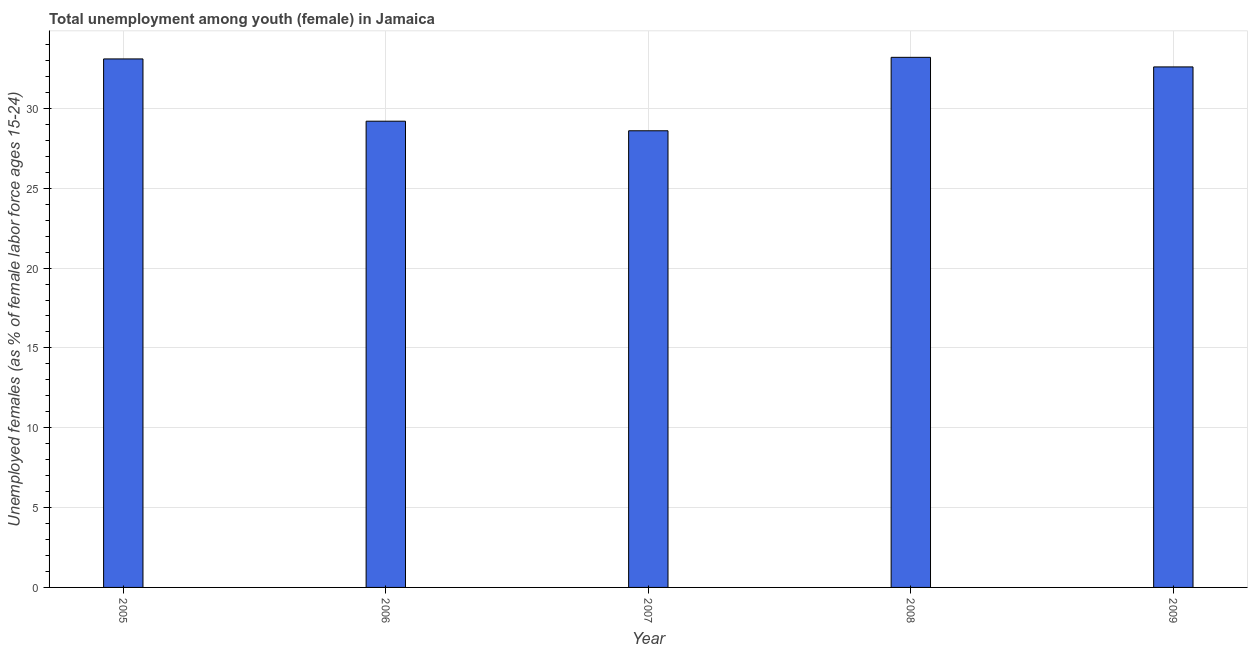Does the graph contain any zero values?
Make the answer very short. No. What is the title of the graph?
Offer a terse response. Total unemployment among youth (female) in Jamaica. What is the label or title of the X-axis?
Provide a short and direct response. Year. What is the label or title of the Y-axis?
Your response must be concise. Unemployed females (as % of female labor force ages 15-24). What is the unemployed female youth population in 2005?
Your answer should be compact. 33.1. Across all years, what is the maximum unemployed female youth population?
Offer a terse response. 33.2. Across all years, what is the minimum unemployed female youth population?
Your answer should be compact. 28.6. In which year was the unemployed female youth population maximum?
Provide a succinct answer. 2008. What is the sum of the unemployed female youth population?
Provide a short and direct response. 156.7. What is the difference between the unemployed female youth population in 2005 and 2008?
Offer a very short reply. -0.1. What is the average unemployed female youth population per year?
Your answer should be compact. 31.34. What is the median unemployed female youth population?
Keep it short and to the point. 32.6. In how many years, is the unemployed female youth population greater than 7 %?
Offer a terse response. 5. Do a majority of the years between 2009 and 2006 (inclusive) have unemployed female youth population greater than 20 %?
Give a very brief answer. Yes. What is the ratio of the unemployed female youth population in 2005 to that in 2006?
Your answer should be very brief. 1.13. Is the sum of the unemployed female youth population in 2005 and 2006 greater than the maximum unemployed female youth population across all years?
Make the answer very short. Yes. What is the difference between the highest and the lowest unemployed female youth population?
Keep it short and to the point. 4.6. Are all the bars in the graph horizontal?
Keep it short and to the point. No. What is the Unemployed females (as % of female labor force ages 15-24) of 2005?
Make the answer very short. 33.1. What is the Unemployed females (as % of female labor force ages 15-24) of 2006?
Give a very brief answer. 29.2. What is the Unemployed females (as % of female labor force ages 15-24) of 2007?
Provide a short and direct response. 28.6. What is the Unemployed females (as % of female labor force ages 15-24) in 2008?
Provide a short and direct response. 33.2. What is the Unemployed females (as % of female labor force ages 15-24) of 2009?
Your answer should be compact. 32.6. What is the difference between the Unemployed females (as % of female labor force ages 15-24) in 2006 and 2008?
Your answer should be very brief. -4. What is the difference between the Unemployed females (as % of female labor force ages 15-24) in 2006 and 2009?
Provide a short and direct response. -3.4. What is the difference between the Unemployed females (as % of female labor force ages 15-24) in 2008 and 2009?
Provide a short and direct response. 0.6. What is the ratio of the Unemployed females (as % of female labor force ages 15-24) in 2005 to that in 2006?
Offer a very short reply. 1.13. What is the ratio of the Unemployed females (as % of female labor force ages 15-24) in 2005 to that in 2007?
Provide a succinct answer. 1.16. What is the ratio of the Unemployed females (as % of female labor force ages 15-24) in 2005 to that in 2009?
Offer a very short reply. 1.01. What is the ratio of the Unemployed females (as % of female labor force ages 15-24) in 2006 to that in 2007?
Offer a very short reply. 1.02. What is the ratio of the Unemployed females (as % of female labor force ages 15-24) in 2006 to that in 2008?
Give a very brief answer. 0.88. What is the ratio of the Unemployed females (as % of female labor force ages 15-24) in 2006 to that in 2009?
Your answer should be compact. 0.9. What is the ratio of the Unemployed females (as % of female labor force ages 15-24) in 2007 to that in 2008?
Offer a terse response. 0.86. What is the ratio of the Unemployed females (as % of female labor force ages 15-24) in 2007 to that in 2009?
Ensure brevity in your answer.  0.88. What is the ratio of the Unemployed females (as % of female labor force ages 15-24) in 2008 to that in 2009?
Provide a short and direct response. 1.02. 